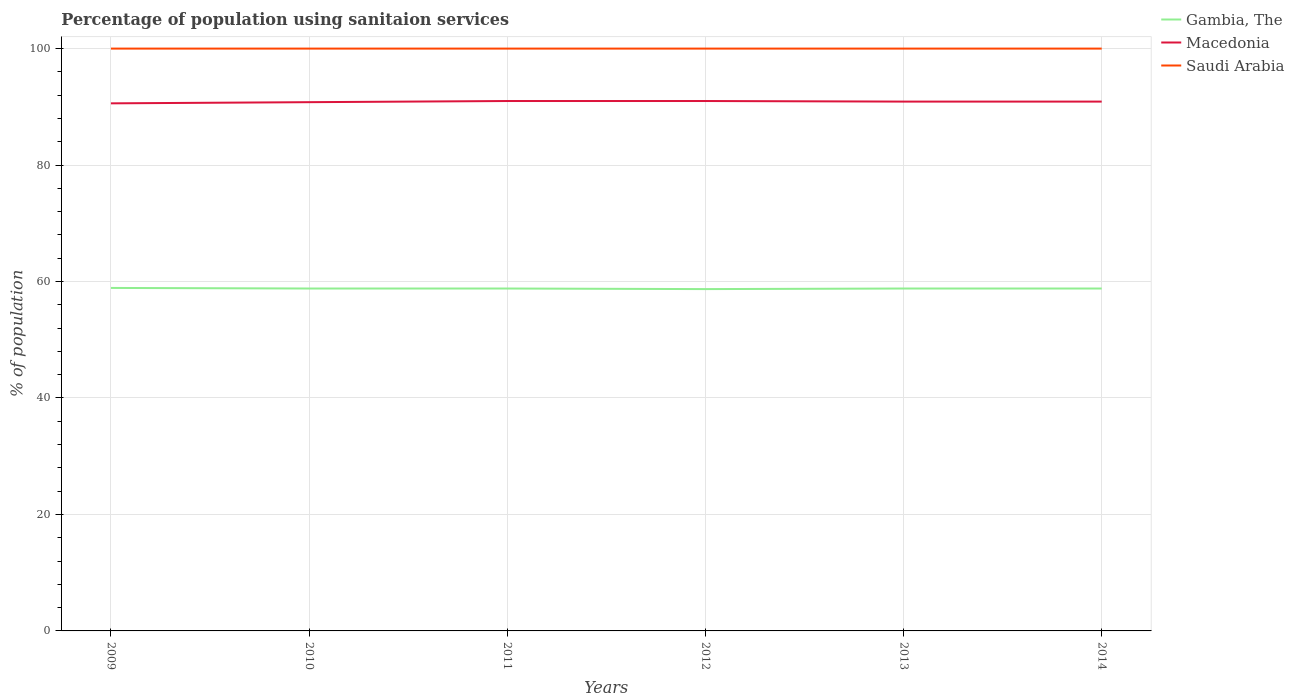How many different coloured lines are there?
Keep it short and to the point. 3. Does the line corresponding to Macedonia intersect with the line corresponding to Saudi Arabia?
Keep it short and to the point. No. Across all years, what is the maximum percentage of population using sanitaion services in Gambia, The?
Your answer should be compact. 58.7. What is the total percentage of population using sanitaion services in Gambia, The in the graph?
Offer a terse response. 0.1. What is the difference between the highest and the second highest percentage of population using sanitaion services in Gambia, The?
Provide a short and direct response. 0.2. Is the percentage of population using sanitaion services in Saudi Arabia strictly greater than the percentage of population using sanitaion services in Gambia, The over the years?
Your answer should be compact. No. Where does the legend appear in the graph?
Your response must be concise. Top right. How many legend labels are there?
Make the answer very short. 3. How are the legend labels stacked?
Your answer should be compact. Vertical. What is the title of the graph?
Give a very brief answer. Percentage of population using sanitaion services. What is the label or title of the Y-axis?
Offer a very short reply. % of population. What is the % of population in Gambia, The in 2009?
Ensure brevity in your answer.  58.9. What is the % of population in Macedonia in 2009?
Offer a terse response. 90.6. What is the % of population of Saudi Arabia in 2009?
Make the answer very short. 100. What is the % of population in Gambia, The in 2010?
Make the answer very short. 58.8. What is the % of population in Macedonia in 2010?
Provide a succinct answer. 90.8. What is the % of population of Gambia, The in 2011?
Provide a succinct answer. 58.8. What is the % of population in Macedonia in 2011?
Your answer should be compact. 91. What is the % of population of Gambia, The in 2012?
Offer a very short reply. 58.7. What is the % of population in Macedonia in 2012?
Provide a short and direct response. 91. What is the % of population in Gambia, The in 2013?
Offer a terse response. 58.8. What is the % of population of Macedonia in 2013?
Make the answer very short. 90.9. What is the % of population of Saudi Arabia in 2013?
Offer a very short reply. 100. What is the % of population of Gambia, The in 2014?
Offer a very short reply. 58.8. What is the % of population of Macedonia in 2014?
Your response must be concise. 90.9. Across all years, what is the maximum % of population in Gambia, The?
Offer a very short reply. 58.9. Across all years, what is the maximum % of population in Macedonia?
Keep it short and to the point. 91. Across all years, what is the minimum % of population in Gambia, The?
Provide a succinct answer. 58.7. Across all years, what is the minimum % of population in Macedonia?
Give a very brief answer. 90.6. Across all years, what is the minimum % of population of Saudi Arabia?
Keep it short and to the point. 100. What is the total % of population in Gambia, The in the graph?
Ensure brevity in your answer.  352.8. What is the total % of population in Macedonia in the graph?
Offer a terse response. 545.2. What is the total % of population of Saudi Arabia in the graph?
Offer a terse response. 600. What is the difference between the % of population in Gambia, The in 2009 and that in 2010?
Ensure brevity in your answer.  0.1. What is the difference between the % of population in Saudi Arabia in 2009 and that in 2010?
Keep it short and to the point. 0. What is the difference between the % of population in Gambia, The in 2009 and that in 2011?
Make the answer very short. 0.1. What is the difference between the % of population in Macedonia in 2009 and that in 2011?
Ensure brevity in your answer.  -0.4. What is the difference between the % of population in Gambia, The in 2009 and that in 2012?
Make the answer very short. 0.2. What is the difference between the % of population in Gambia, The in 2009 and that in 2013?
Provide a short and direct response. 0.1. What is the difference between the % of population in Macedonia in 2009 and that in 2013?
Provide a succinct answer. -0.3. What is the difference between the % of population of Saudi Arabia in 2009 and that in 2013?
Offer a very short reply. 0. What is the difference between the % of population of Macedonia in 2009 and that in 2014?
Offer a very short reply. -0.3. What is the difference between the % of population of Gambia, The in 2010 and that in 2011?
Offer a very short reply. 0. What is the difference between the % of population in Macedonia in 2010 and that in 2011?
Keep it short and to the point. -0.2. What is the difference between the % of population in Saudi Arabia in 2010 and that in 2011?
Your response must be concise. 0. What is the difference between the % of population of Gambia, The in 2010 and that in 2012?
Your answer should be very brief. 0.1. What is the difference between the % of population in Macedonia in 2010 and that in 2012?
Your answer should be compact. -0.2. What is the difference between the % of population in Saudi Arabia in 2010 and that in 2012?
Your answer should be compact. 0. What is the difference between the % of population of Macedonia in 2010 and that in 2013?
Keep it short and to the point. -0.1. What is the difference between the % of population of Saudi Arabia in 2010 and that in 2013?
Your answer should be very brief. 0. What is the difference between the % of population in Gambia, The in 2010 and that in 2014?
Your answer should be very brief. 0. What is the difference between the % of population in Macedonia in 2010 and that in 2014?
Ensure brevity in your answer.  -0.1. What is the difference between the % of population in Saudi Arabia in 2010 and that in 2014?
Keep it short and to the point. 0. What is the difference between the % of population of Gambia, The in 2011 and that in 2012?
Offer a very short reply. 0.1. What is the difference between the % of population of Gambia, The in 2011 and that in 2013?
Offer a terse response. 0. What is the difference between the % of population of Macedonia in 2011 and that in 2013?
Your answer should be very brief. 0.1. What is the difference between the % of population in Saudi Arabia in 2011 and that in 2013?
Your answer should be very brief. 0. What is the difference between the % of population in Macedonia in 2011 and that in 2014?
Your answer should be compact. 0.1. What is the difference between the % of population in Saudi Arabia in 2012 and that in 2013?
Offer a terse response. 0. What is the difference between the % of population of Macedonia in 2012 and that in 2014?
Provide a short and direct response. 0.1. What is the difference between the % of population of Macedonia in 2013 and that in 2014?
Offer a very short reply. 0. What is the difference between the % of population in Gambia, The in 2009 and the % of population in Macedonia in 2010?
Offer a terse response. -31.9. What is the difference between the % of population in Gambia, The in 2009 and the % of population in Saudi Arabia in 2010?
Provide a succinct answer. -41.1. What is the difference between the % of population of Macedonia in 2009 and the % of population of Saudi Arabia in 2010?
Keep it short and to the point. -9.4. What is the difference between the % of population of Gambia, The in 2009 and the % of population of Macedonia in 2011?
Your response must be concise. -32.1. What is the difference between the % of population of Gambia, The in 2009 and the % of population of Saudi Arabia in 2011?
Provide a short and direct response. -41.1. What is the difference between the % of population of Macedonia in 2009 and the % of population of Saudi Arabia in 2011?
Offer a terse response. -9.4. What is the difference between the % of population of Gambia, The in 2009 and the % of population of Macedonia in 2012?
Give a very brief answer. -32.1. What is the difference between the % of population in Gambia, The in 2009 and the % of population in Saudi Arabia in 2012?
Your answer should be very brief. -41.1. What is the difference between the % of population in Macedonia in 2009 and the % of population in Saudi Arabia in 2012?
Your response must be concise. -9.4. What is the difference between the % of population in Gambia, The in 2009 and the % of population in Macedonia in 2013?
Offer a terse response. -32. What is the difference between the % of population in Gambia, The in 2009 and the % of population in Saudi Arabia in 2013?
Give a very brief answer. -41.1. What is the difference between the % of population in Macedonia in 2009 and the % of population in Saudi Arabia in 2013?
Ensure brevity in your answer.  -9.4. What is the difference between the % of population in Gambia, The in 2009 and the % of population in Macedonia in 2014?
Give a very brief answer. -32. What is the difference between the % of population in Gambia, The in 2009 and the % of population in Saudi Arabia in 2014?
Your answer should be very brief. -41.1. What is the difference between the % of population in Macedonia in 2009 and the % of population in Saudi Arabia in 2014?
Your response must be concise. -9.4. What is the difference between the % of population of Gambia, The in 2010 and the % of population of Macedonia in 2011?
Your response must be concise. -32.2. What is the difference between the % of population in Gambia, The in 2010 and the % of population in Saudi Arabia in 2011?
Provide a short and direct response. -41.2. What is the difference between the % of population of Gambia, The in 2010 and the % of population of Macedonia in 2012?
Your answer should be very brief. -32.2. What is the difference between the % of population of Gambia, The in 2010 and the % of population of Saudi Arabia in 2012?
Make the answer very short. -41.2. What is the difference between the % of population in Gambia, The in 2010 and the % of population in Macedonia in 2013?
Provide a short and direct response. -32.1. What is the difference between the % of population of Gambia, The in 2010 and the % of population of Saudi Arabia in 2013?
Ensure brevity in your answer.  -41.2. What is the difference between the % of population of Gambia, The in 2010 and the % of population of Macedonia in 2014?
Your answer should be very brief. -32.1. What is the difference between the % of population of Gambia, The in 2010 and the % of population of Saudi Arabia in 2014?
Give a very brief answer. -41.2. What is the difference between the % of population of Macedonia in 2010 and the % of population of Saudi Arabia in 2014?
Your answer should be very brief. -9.2. What is the difference between the % of population of Gambia, The in 2011 and the % of population of Macedonia in 2012?
Keep it short and to the point. -32.2. What is the difference between the % of population of Gambia, The in 2011 and the % of population of Saudi Arabia in 2012?
Keep it short and to the point. -41.2. What is the difference between the % of population in Macedonia in 2011 and the % of population in Saudi Arabia in 2012?
Make the answer very short. -9. What is the difference between the % of population of Gambia, The in 2011 and the % of population of Macedonia in 2013?
Offer a terse response. -32.1. What is the difference between the % of population in Gambia, The in 2011 and the % of population in Saudi Arabia in 2013?
Keep it short and to the point. -41.2. What is the difference between the % of population of Macedonia in 2011 and the % of population of Saudi Arabia in 2013?
Your answer should be very brief. -9. What is the difference between the % of population in Gambia, The in 2011 and the % of population in Macedonia in 2014?
Offer a very short reply. -32.1. What is the difference between the % of population in Gambia, The in 2011 and the % of population in Saudi Arabia in 2014?
Offer a very short reply. -41.2. What is the difference between the % of population in Gambia, The in 2012 and the % of population in Macedonia in 2013?
Offer a terse response. -32.2. What is the difference between the % of population in Gambia, The in 2012 and the % of population in Saudi Arabia in 2013?
Offer a very short reply. -41.3. What is the difference between the % of population in Macedonia in 2012 and the % of population in Saudi Arabia in 2013?
Keep it short and to the point. -9. What is the difference between the % of population in Gambia, The in 2012 and the % of population in Macedonia in 2014?
Make the answer very short. -32.2. What is the difference between the % of population in Gambia, The in 2012 and the % of population in Saudi Arabia in 2014?
Provide a short and direct response. -41.3. What is the difference between the % of population of Gambia, The in 2013 and the % of population of Macedonia in 2014?
Give a very brief answer. -32.1. What is the difference between the % of population of Gambia, The in 2013 and the % of population of Saudi Arabia in 2014?
Give a very brief answer. -41.2. What is the average % of population in Gambia, The per year?
Keep it short and to the point. 58.8. What is the average % of population of Macedonia per year?
Offer a very short reply. 90.87. In the year 2009, what is the difference between the % of population in Gambia, The and % of population in Macedonia?
Offer a terse response. -31.7. In the year 2009, what is the difference between the % of population in Gambia, The and % of population in Saudi Arabia?
Give a very brief answer. -41.1. In the year 2009, what is the difference between the % of population of Macedonia and % of population of Saudi Arabia?
Keep it short and to the point. -9.4. In the year 2010, what is the difference between the % of population in Gambia, The and % of population in Macedonia?
Give a very brief answer. -32. In the year 2010, what is the difference between the % of population of Gambia, The and % of population of Saudi Arabia?
Give a very brief answer. -41.2. In the year 2010, what is the difference between the % of population of Macedonia and % of population of Saudi Arabia?
Ensure brevity in your answer.  -9.2. In the year 2011, what is the difference between the % of population in Gambia, The and % of population in Macedonia?
Provide a short and direct response. -32.2. In the year 2011, what is the difference between the % of population of Gambia, The and % of population of Saudi Arabia?
Ensure brevity in your answer.  -41.2. In the year 2012, what is the difference between the % of population in Gambia, The and % of population in Macedonia?
Offer a very short reply. -32.3. In the year 2012, what is the difference between the % of population in Gambia, The and % of population in Saudi Arabia?
Provide a short and direct response. -41.3. In the year 2013, what is the difference between the % of population in Gambia, The and % of population in Macedonia?
Keep it short and to the point. -32.1. In the year 2013, what is the difference between the % of population of Gambia, The and % of population of Saudi Arabia?
Provide a short and direct response. -41.2. In the year 2014, what is the difference between the % of population in Gambia, The and % of population in Macedonia?
Your response must be concise. -32.1. In the year 2014, what is the difference between the % of population in Gambia, The and % of population in Saudi Arabia?
Your answer should be compact. -41.2. What is the ratio of the % of population of Macedonia in 2009 to that in 2010?
Your answer should be very brief. 1. What is the ratio of the % of population of Gambia, The in 2009 to that in 2012?
Keep it short and to the point. 1. What is the ratio of the % of population of Macedonia in 2009 to that in 2012?
Offer a very short reply. 1. What is the ratio of the % of population of Gambia, The in 2009 to that in 2013?
Your answer should be compact. 1. What is the ratio of the % of population of Macedonia in 2009 to that in 2013?
Ensure brevity in your answer.  1. What is the ratio of the % of population in Gambia, The in 2009 to that in 2014?
Make the answer very short. 1. What is the ratio of the % of population of Gambia, The in 2010 to that in 2011?
Your answer should be compact. 1. What is the ratio of the % of population of Macedonia in 2010 to that in 2011?
Make the answer very short. 1. What is the ratio of the % of population of Gambia, The in 2010 to that in 2012?
Offer a very short reply. 1. What is the ratio of the % of population of Gambia, The in 2010 to that in 2013?
Make the answer very short. 1. What is the ratio of the % of population in Macedonia in 2010 to that in 2013?
Your response must be concise. 1. What is the ratio of the % of population in Gambia, The in 2010 to that in 2014?
Ensure brevity in your answer.  1. What is the ratio of the % of population of Macedonia in 2010 to that in 2014?
Your response must be concise. 1. What is the ratio of the % of population of Gambia, The in 2011 to that in 2012?
Ensure brevity in your answer.  1. What is the ratio of the % of population of Gambia, The in 2011 to that in 2013?
Provide a short and direct response. 1. What is the ratio of the % of population in Macedonia in 2011 to that in 2013?
Your answer should be very brief. 1. What is the ratio of the % of population in Macedonia in 2013 to that in 2014?
Give a very brief answer. 1. What is the ratio of the % of population in Saudi Arabia in 2013 to that in 2014?
Make the answer very short. 1. What is the difference between the highest and the second highest % of population of Gambia, The?
Your answer should be very brief. 0.1. What is the difference between the highest and the second highest % of population in Macedonia?
Your answer should be compact. 0. What is the difference between the highest and the lowest % of population in Saudi Arabia?
Give a very brief answer. 0. 